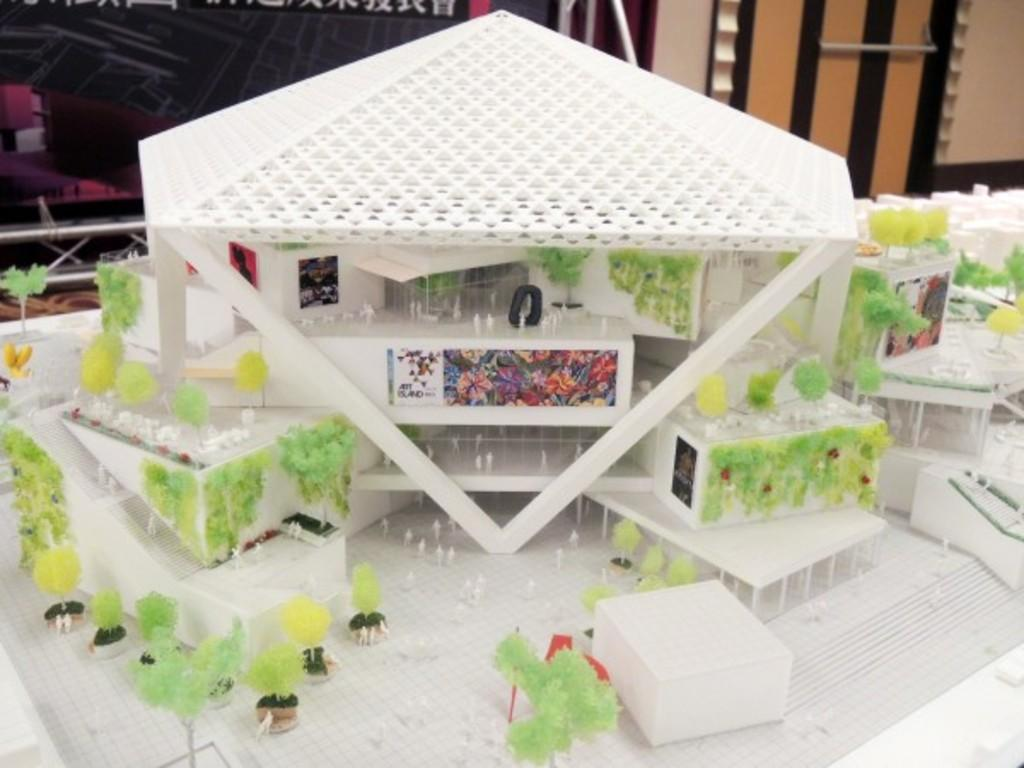What is the main subject on the table in the image? There is a miniature house on a table in the image. What type of vegetation can be seen in the image? There are plants and trees in the image. What else is present on the table besides the miniature house? Other unspecified objects are present on the table. Can you describe the door visible in the image? There is a door visible in the image. How does the society depicted in the image react to the end of anger? There is no depiction of society, the end of anger, or any reaction in the image. 